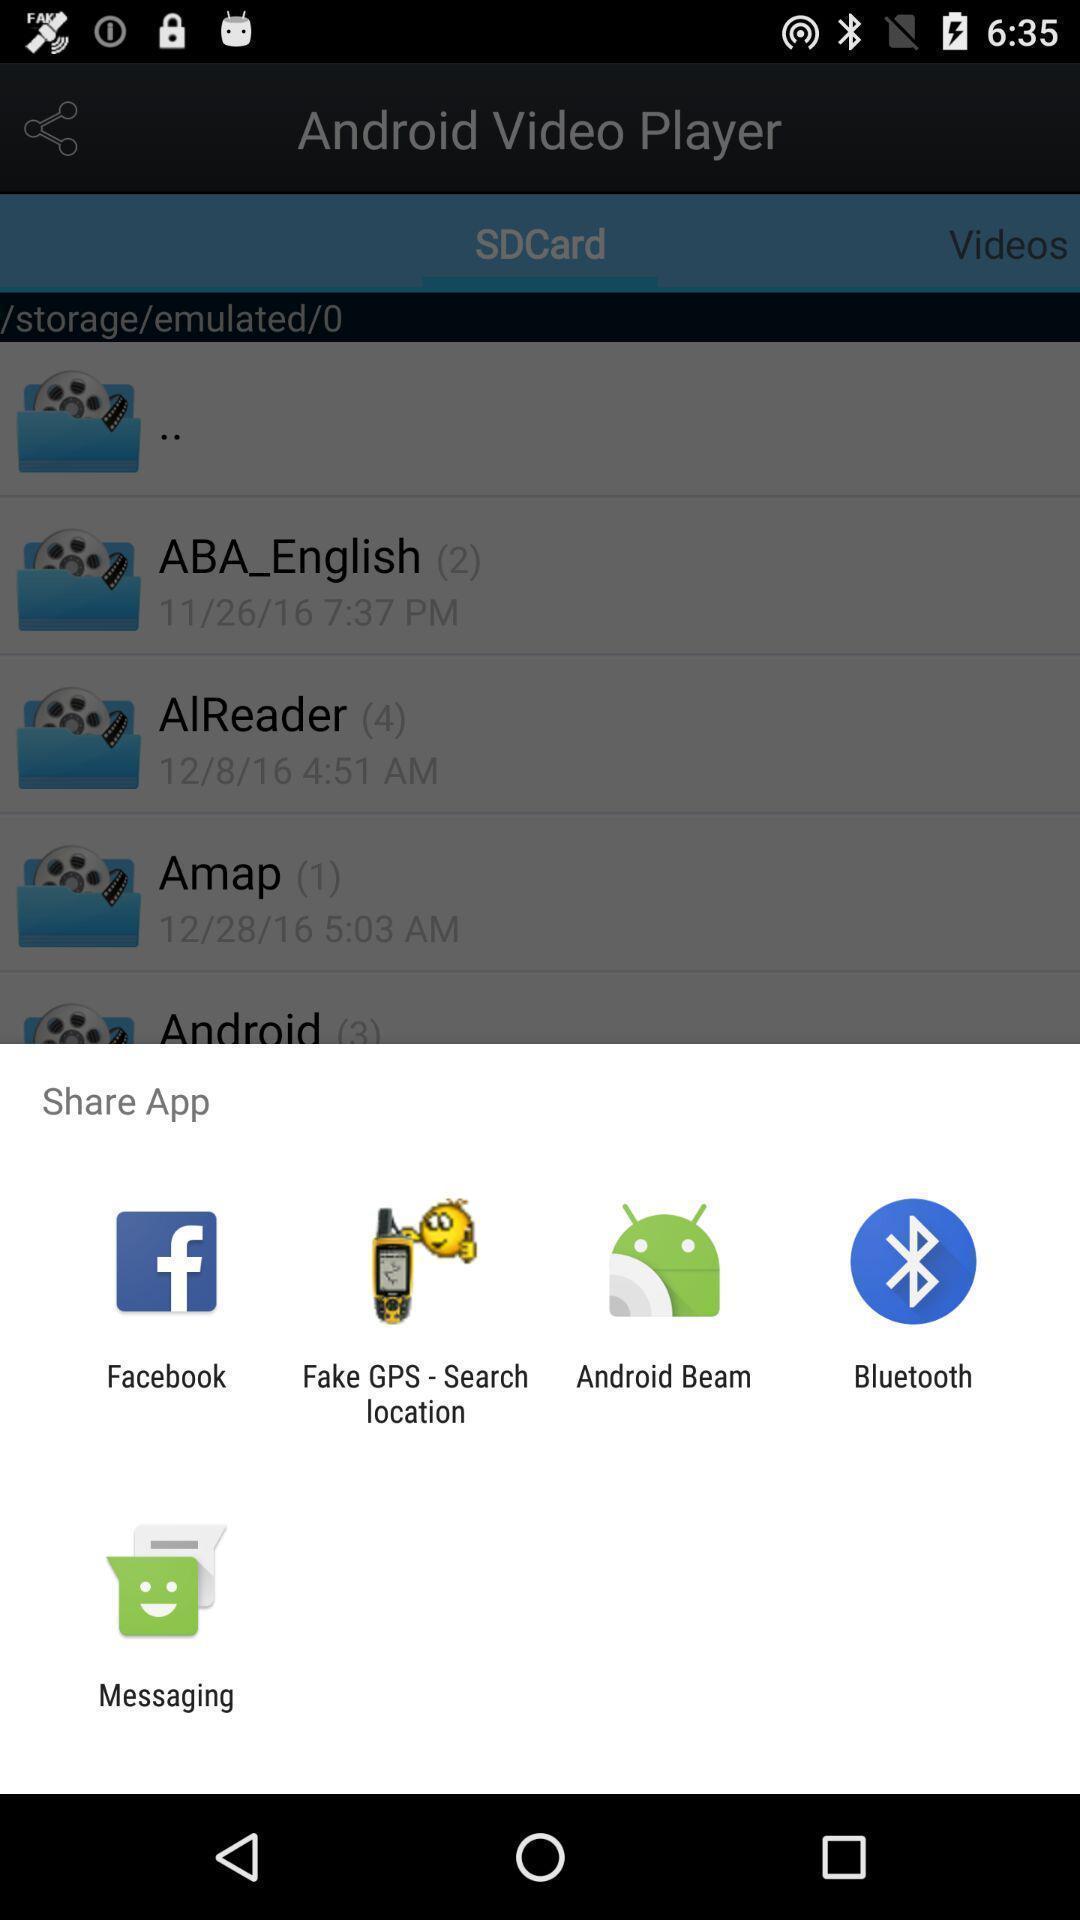Describe the visual elements of this screenshot. Pop-up showing different sharing options. 